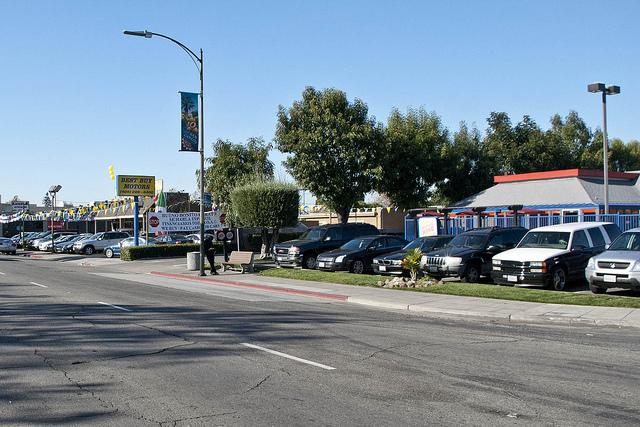What item does the business with banners in front of it sell? Please explain your reasoning. cars. The sign in the yellow says what is sold there. 